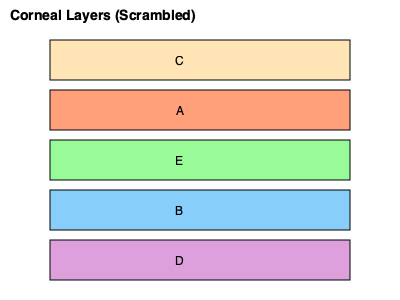Reconstruct the correct order of corneal layers from anterior to posterior using the scrambled cross-sectional images labeled A through E. Provide your answer as a sequence of letters. To reconstruct the correct order of corneal layers, we need to recall the anatomical structure of the cornea from anterior to posterior:

1. Epithelium: The outermost layer of the cornea, which is in direct contact with the environment.
2. Bowman's layer: A thin, acellular layer beneath the epithelium.
3. Stroma: The thickest layer of the cornea, comprising about 90% of its thickness.
4. Descemet's membrane: A thin, elastic layer that serves as the basement membrane for the endothelium.
5. Endothelium: The innermost layer of the cornea, in contact with the aqueous humor.

Now, let's match these layers to the scrambled images:

A (Light salmon color): This represents the stroma, the thickest layer.
B (Light blue color): This likely represents the epithelium, the outermost layer.
C (Light orange color): This thin layer represents Bowman's layer.
D (Light purple color): This thin layer at the bottom represents the endothelium.
E (Light green color): This thin layer above the endothelium represents Descemet's membrane.

Therefore, the correct order from anterior to posterior is:

B (Epithelium) → C (Bowman's layer) → A (Stroma) → E (Descemet's membrane) → D (Endothelium)
Answer: BCAED 